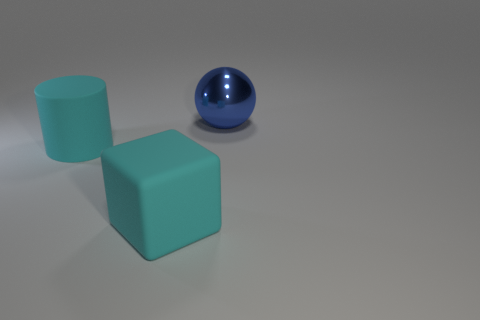Add 2 cyan objects. How many objects exist? 5 Add 3 large cyan objects. How many large cyan objects are left? 5 Add 2 red metal blocks. How many red metal blocks exist? 2 Subtract 0 gray balls. How many objects are left? 3 Subtract all spheres. How many objects are left? 2 Subtract all purple cubes. Subtract all blue spheres. How many cubes are left? 1 Subtract all blue metal things. Subtract all large cyan matte cylinders. How many objects are left? 1 